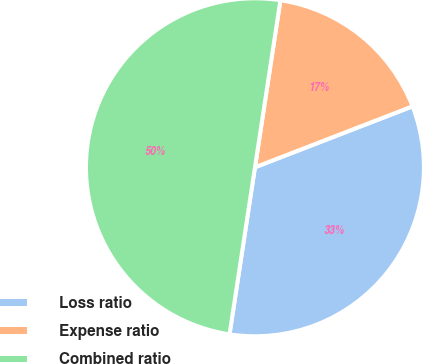<chart> <loc_0><loc_0><loc_500><loc_500><pie_chart><fcel>Loss ratio<fcel>Expense ratio<fcel>Combined ratio<nl><fcel>33.28%<fcel>16.72%<fcel>50.0%<nl></chart> 